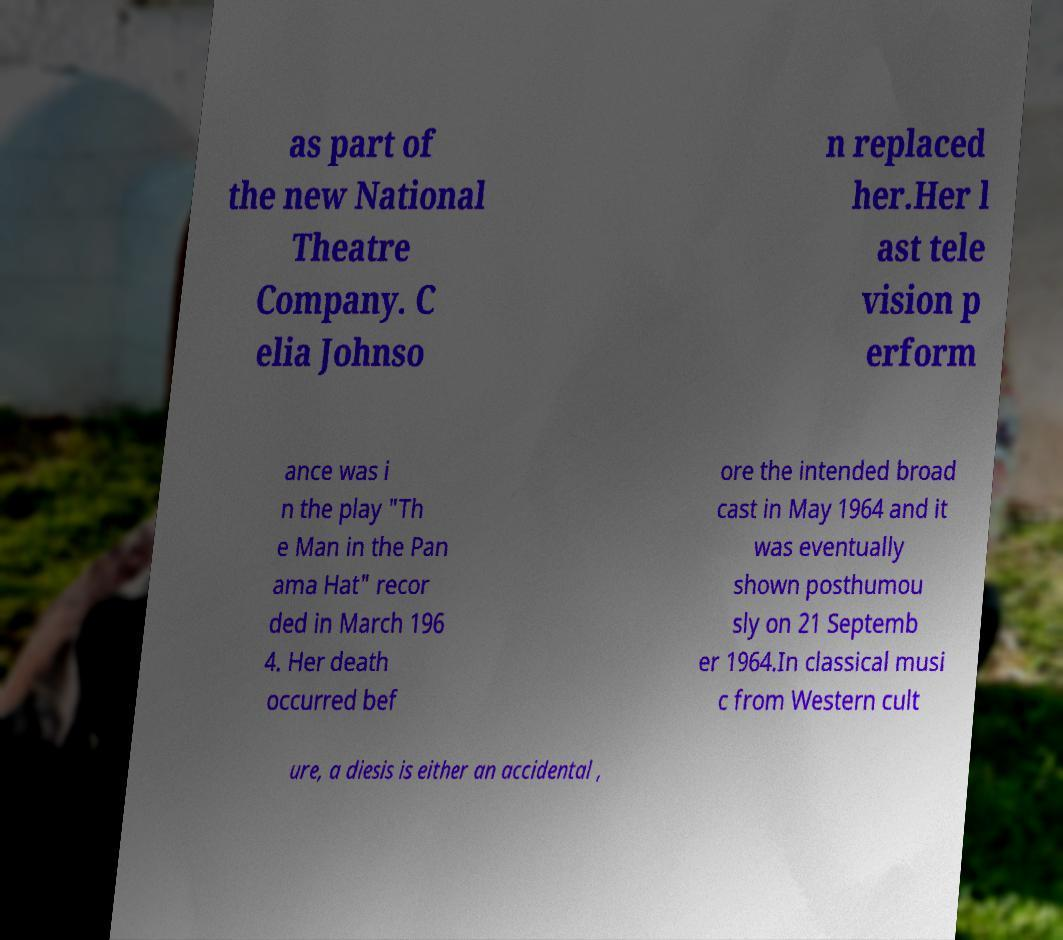Can you accurately transcribe the text from the provided image for me? as part of the new National Theatre Company. C elia Johnso n replaced her.Her l ast tele vision p erform ance was i n the play "Th e Man in the Pan ama Hat" recor ded in March 196 4. Her death occurred bef ore the intended broad cast in May 1964 and it was eventually shown posthumou sly on 21 Septemb er 1964.In classical musi c from Western cult ure, a diesis is either an accidental , 